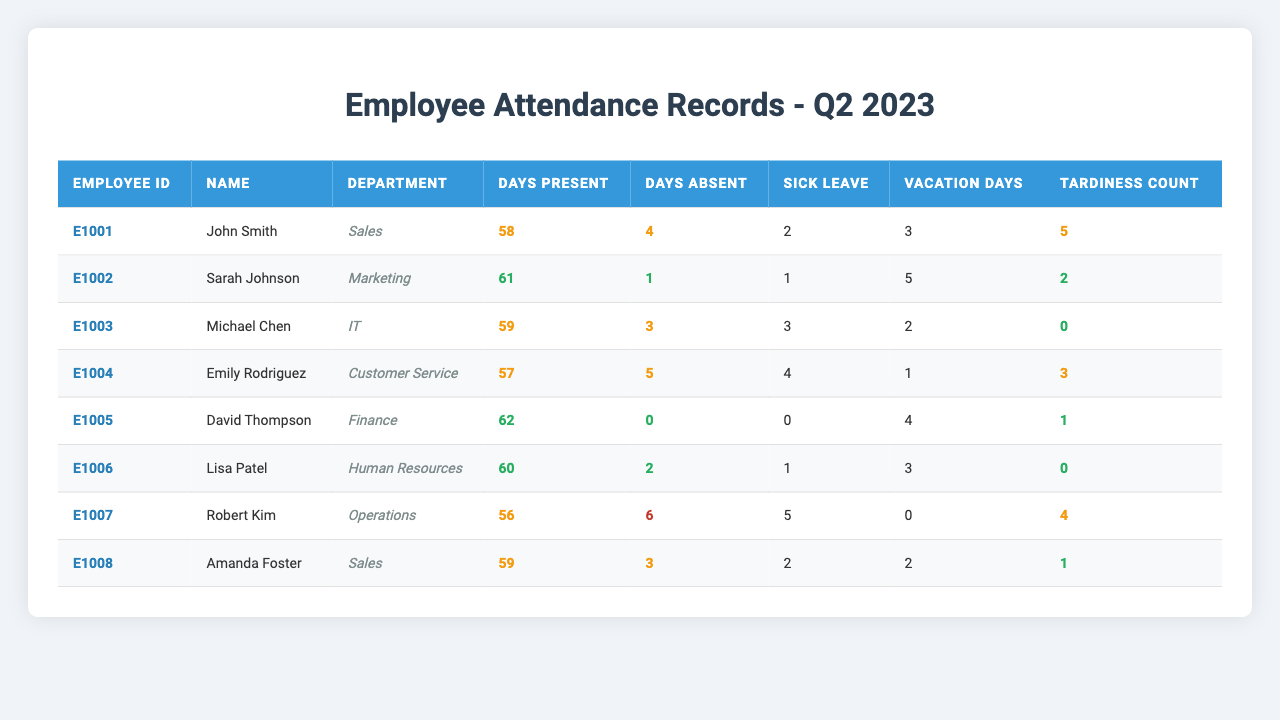What is the name of the employee with the highest number of days present? Looking at the "Days Present" column, David Thompson (E1005) has 62 days present, which is the highest compared to others.
Answer: David Thompson How many total days absent do all employees have combined? To find the total days absent, we sum the "Days Absent" column: 4 + 1 + 3 + 5 + 0 + 2 + 6 + 3 = 24.
Answer: 24 Who has the highest tardiness count, and what is that count? By checking the "Tardiness Count" column, Robert Kim (E1007) has the highest count at 4.
Answer: Robert Kim, 4 Is there any employee who has taken sick leave more than 3 times? Checking the "Sick Leave" column, Robert Kim has taken 5 sick leave days, which is more than 3.
Answer: Yes Calculate the average number of vacation days taken by employees. Summing the "Vacation Days" column results in 3 + 5 + 2 + 1 + 4 + 3 + 0 + 2 = 20 and there are 8 employees, so the average is 20/8 = 2.5.
Answer: 2.5 Which department has the employee with the least days present? The least days present is 56 from Robert Kim in the Operations department.
Answer: Operations Is John Smith's attendance categorized as good? John Smith has 58 days present, which falls under the 'attendance-warning' category indicating it's not good.
Answer: No How many employees have taken vacation days of 3 or more? Looking at the "Vacation Days" column, Sarah Johnson, David Thompson, Lisa Patel each took more than 3 vacation days. Therefore, there are 3.
Answer: 3 What is the difference in sick leave between the employee with the most and the least sick leave? Robert Kim has 5 sick leave days (most) and David Thompson has 0 sick leave days (least). The difference is 5 - 0 = 5.
Answer: 5 Who in the Sales department has more days absent, John Smith or Amanda Foster? John Smith has 4 days absent and Amanda Foster has 3 days absent. Therefore, John Smith has more days absent.
Answer: John Smith 